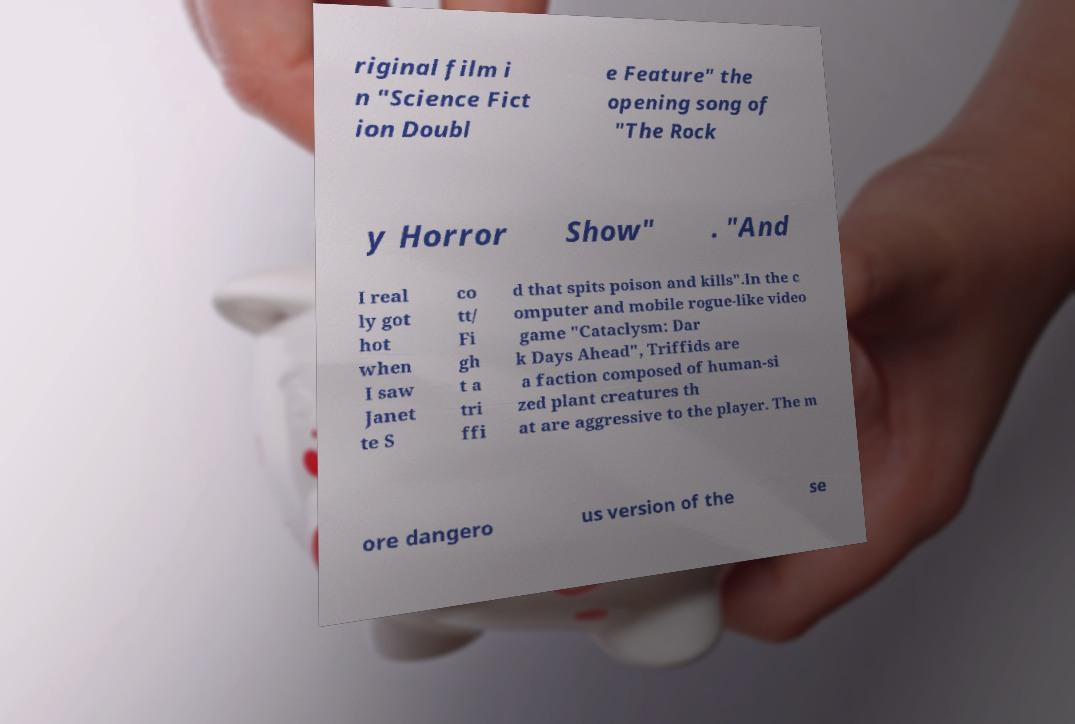Can you read and provide the text displayed in the image?This photo seems to have some interesting text. Can you extract and type it out for me? riginal film i n "Science Fict ion Doubl e Feature" the opening song of "The Rock y Horror Show" . "And I real ly got hot when I saw Janet te S co tt/ Fi gh t a tri ffi d that spits poison and kills".In the c omputer and mobile rogue-like video game "Cataclysm: Dar k Days Ahead", Triffids are a faction composed of human-si zed plant creatures th at are aggressive to the player. The m ore dangero us version of the se 